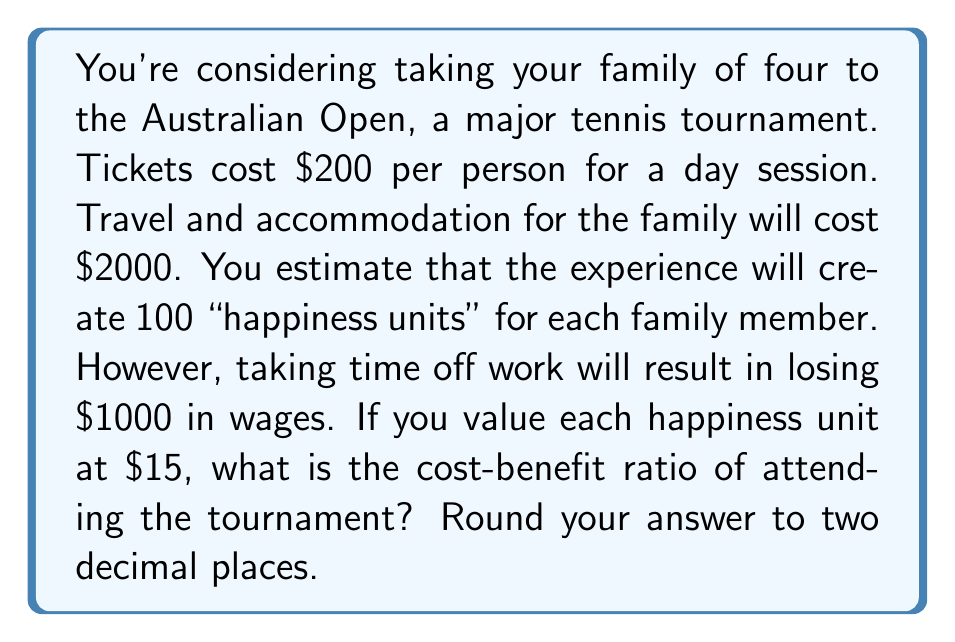Give your solution to this math problem. Let's break this problem down step by step:

1. Calculate the total cost:
   * Ticket cost: $200 × 4 people = $800
   * Travel and accommodation: $2000
   * Lost wages: $1000
   * Total cost: $C = 800 + 2000 + 1000 = $3800

2. Calculate the total benefit:
   * Happiness units: 100 per person × 4 people = 400 units
   * Value per happiness unit: $15
   * Total benefit: $B = 400 × $15 = $6000

3. Calculate the cost-benefit ratio:
   The cost-benefit ratio is defined as:

   $$\text{Cost-Benefit Ratio} = \frac{\text{Cost}}{\text{Benefit}}$$

   Substituting our values:

   $$\text{Cost-Benefit Ratio} = \frac{C}{B} = \frac{3800}{6000}$$

4. Simplify the fraction:
   $$\frac{3800}{6000} = \frac{19}{30} \approx 0.6333$$

5. Round to two decimal places:
   0.63

Therefore, the cost-benefit ratio of attending the tournament is 0.63.
Answer: 0.63 